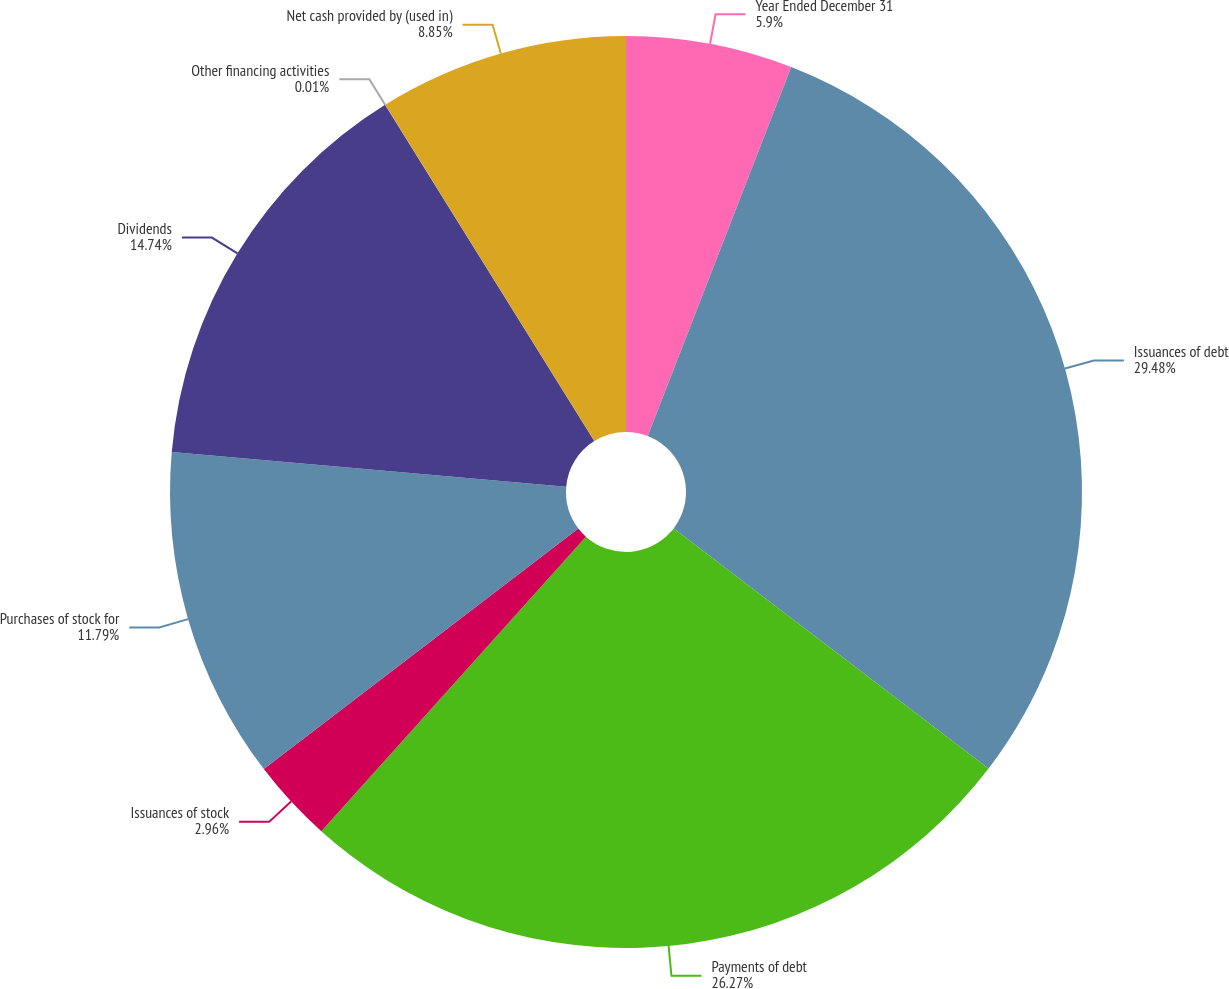<chart> <loc_0><loc_0><loc_500><loc_500><pie_chart><fcel>Year Ended December 31<fcel>Issuances of debt<fcel>Payments of debt<fcel>Issuances of stock<fcel>Purchases of stock for<fcel>Dividends<fcel>Other financing activities<fcel>Net cash provided by (used in)<nl><fcel>5.9%<fcel>29.47%<fcel>26.27%<fcel>2.96%<fcel>11.79%<fcel>14.74%<fcel>0.01%<fcel>8.85%<nl></chart> 